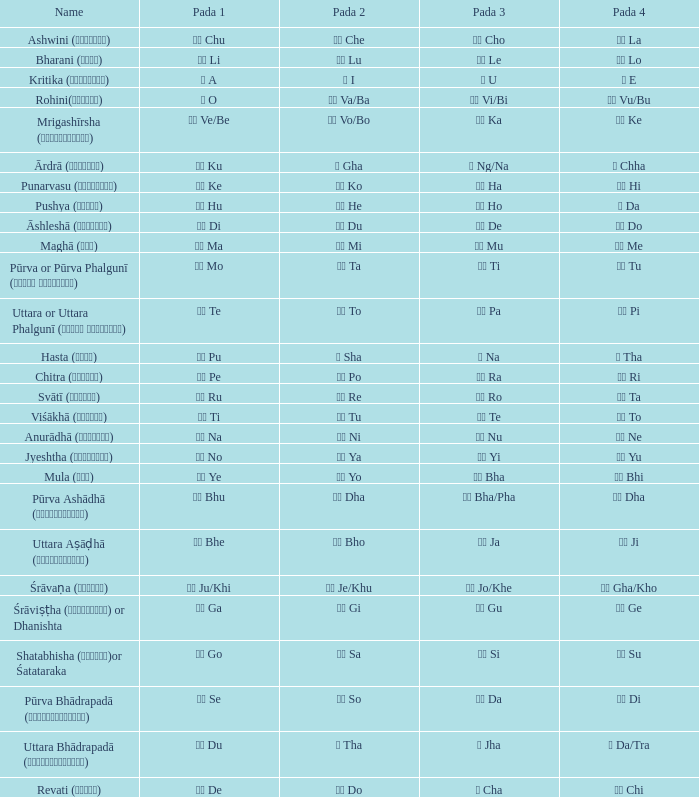Which Pada 3 has a Pada 1 of टे te? पा Pa. 